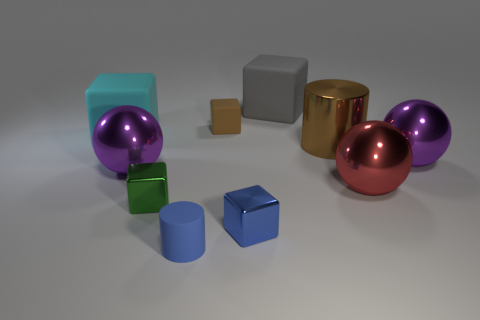There is a gray object that is the same shape as the blue metal thing; what is its material?
Your answer should be very brief. Rubber. The large matte object behind the large matte thing to the left of the small cylinder is what color?
Provide a succinct answer. Gray. Is there anything else that has the same size as the cyan thing?
Give a very brief answer. Yes. Do the small rubber thing that is in front of the big red sphere and the brown shiny object have the same shape?
Keep it short and to the point. Yes. How many things are both to the left of the green block and behind the shiny cylinder?
Ensure brevity in your answer.  1. What color is the small thing that is behind the purple object right of the sphere left of the small blue rubber cylinder?
Give a very brief answer. Brown. There is a purple metallic object that is right of the red metal thing; how many green metal objects are on the left side of it?
Provide a short and direct response. 1. What number of other things are the same shape as the tiny brown matte object?
Your answer should be compact. 4. How many things are either tiny blue matte objects or tiny things that are left of the blue shiny object?
Provide a succinct answer. 3. Is the number of cylinders that are to the left of the large brown metallic object greater than the number of small rubber objects to the right of the blue shiny thing?
Provide a succinct answer. Yes. 